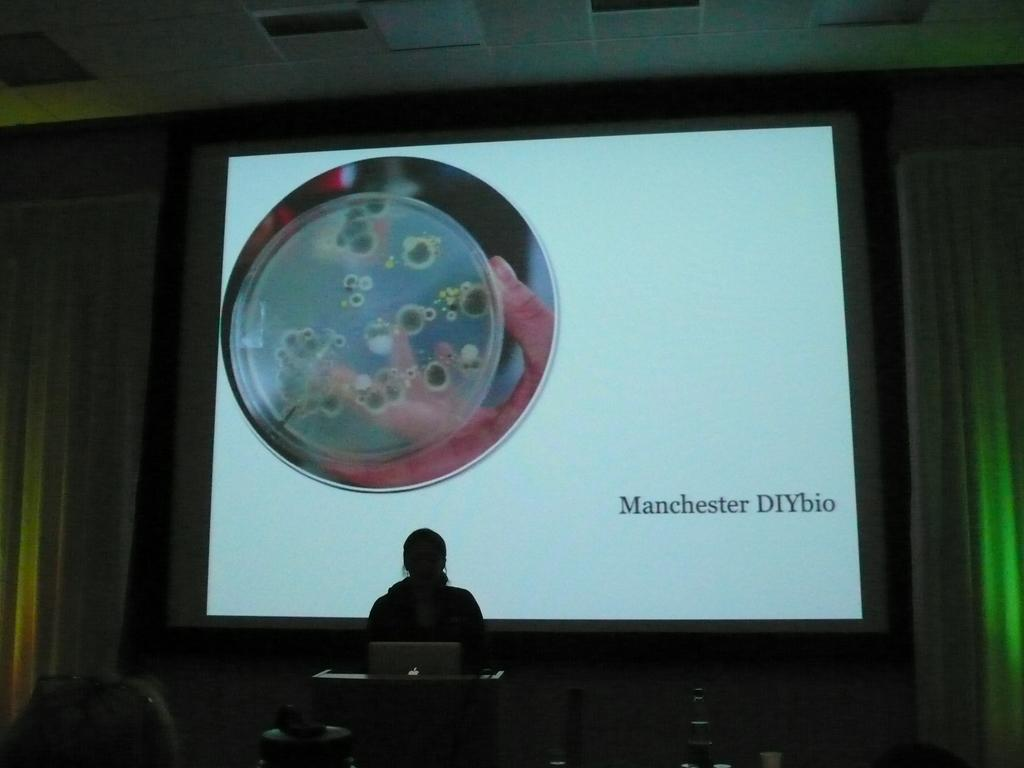<image>
Summarize the visual content of the image. a person speaking in front of a laptop with a Manchester photo behind them 